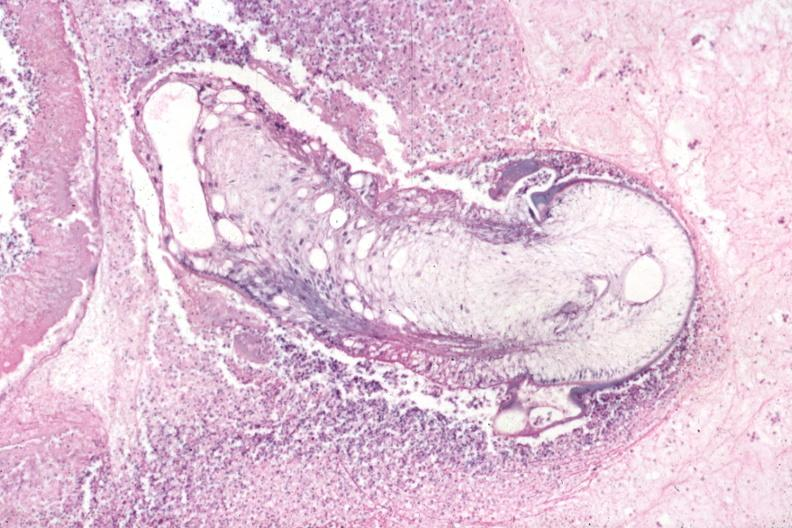what is present?
Answer the question using a single word or phrase. Eye 